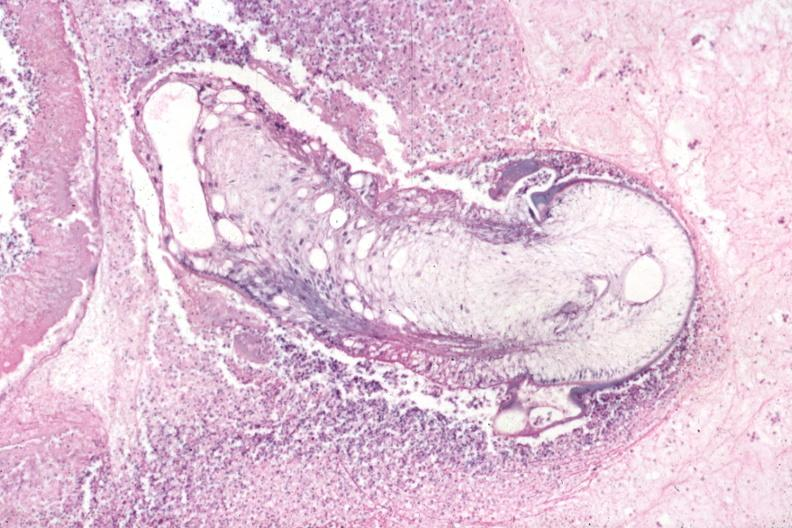what is present?
Answer the question using a single word or phrase. Eye 